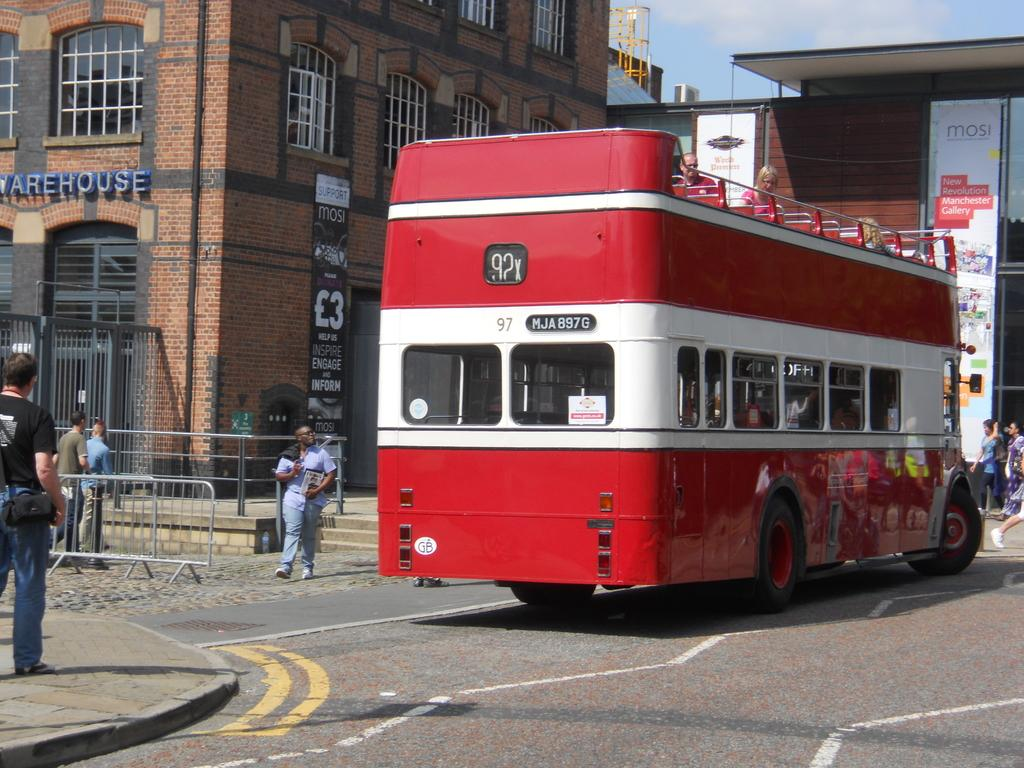<image>
Offer a succinct explanation of the picture presented. A red open topped bus with the number 92 on the back 